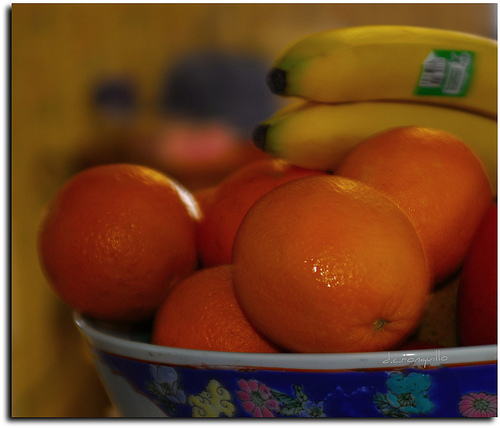<image>
Is the fruit on the bowl? Yes. Looking at the image, I can see the fruit is positioned on top of the bowl, with the bowl providing support. Where is the orange in relation to the bowl? Is it on the bowl? Yes. Looking at the image, I can see the orange is positioned on top of the bowl, with the bowl providing support. 